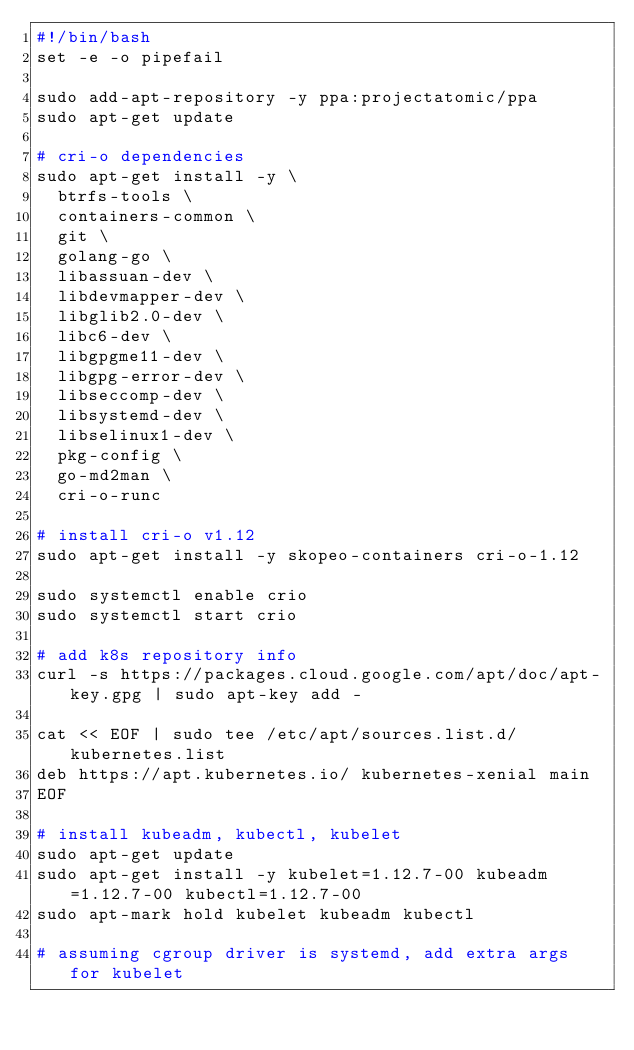Convert code to text. <code><loc_0><loc_0><loc_500><loc_500><_Bash_>#!/bin/bash
set -e -o pipefail

sudo add-apt-repository -y ppa:projectatomic/ppa
sudo apt-get update

# cri-o dependencies
sudo apt-get install -y \
  btrfs-tools \
  containers-common \
  git \
  golang-go \
  libassuan-dev \
  libdevmapper-dev \
  libglib2.0-dev \
  libc6-dev \
  libgpgme11-dev \
  libgpg-error-dev \
  libseccomp-dev \
  libsystemd-dev \
  libselinux1-dev \
  pkg-config \
  go-md2man \
  cri-o-runc

# install cri-o v1.12
sudo apt-get install -y skopeo-containers cri-o-1.12

sudo systemctl enable crio
sudo systemctl start crio

# add k8s repository info
curl -s https://packages.cloud.google.com/apt/doc/apt-key.gpg | sudo apt-key add -

cat << EOF | sudo tee /etc/apt/sources.list.d/kubernetes.list
deb https://apt.kubernetes.io/ kubernetes-xenial main
EOF

# install kubeadm, kubectl, kubelet
sudo apt-get update
sudo apt-get install -y kubelet=1.12.7-00 kubeadm=1.12.7-00 kubectl=1.12.7-00
sudo apt-mark hold kubelet kubeadm kubectl

# assuming cgroup driver is systemd, add extra args for kubelet</code> 